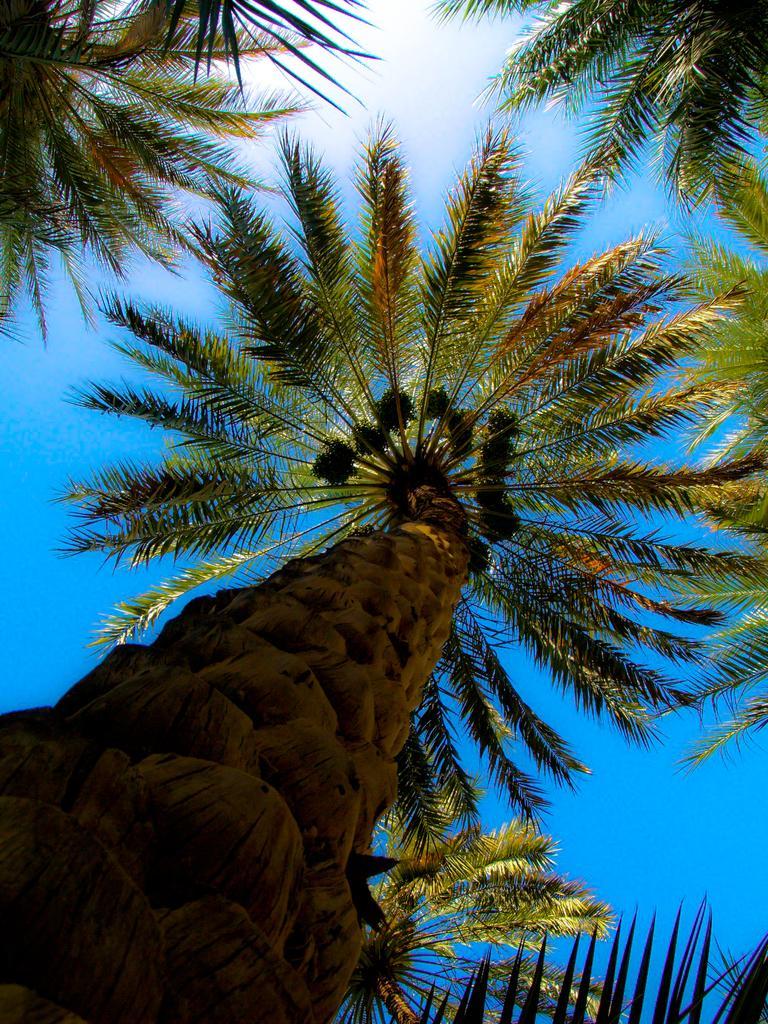What type of vegetation can be seen in the image? There are trees in the image. What is located at the bottom of the image? There is a trunk at the bottom of the image. What can be seen in the background of the image? The sky is visible in the background of the image. What type of nose can be seen on the trees in the image? There are no noses present on the trees in the image, as trees do not have noses. 